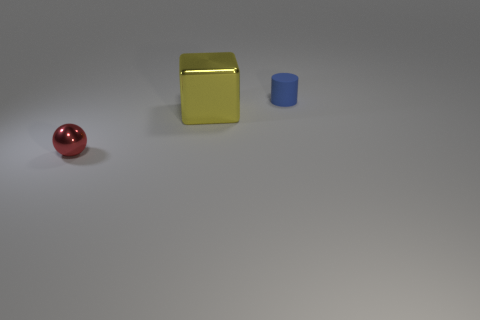What number of other things are there of the same size as the sphere?
Your answer should be compact. 1. What shape is the other thing that is the same size as the blue object?
Your answer should be very brief. Sphere. There is a tiny thing that is to the right of the tiny object that is in front of the tiny blue rubber object; are there any tiny objects that are to the right of it?
Your answer should be very brief. No. Is there a rubber thing of the same size as the red metallic object?
Give a very brief answer. Yes. There is a thing that is in front of the yellow metallic thing; how big is it?
Your response must be concise. Small. The metallic object in front of the metallic thing to the right of the tiny thing on the left side of the small blue thing is what color?
Ensure brevity in your answer.  Red. What is the color of the metallic thing on the right side of the thing in front of the big yellow object?
Your response must be concise. Yellow. Is the number of rubber objects that are behind the tiny red ball greater than the number of metallic things that are right of the blue cylinder?
Offer a very short reply. Yes. Are there any objects in front of the tiny cylinder?
Provide a succinct answer. Yes. What number of red things are either large metal cubes or shiny spheres?
Keep it short and to the point. 1. 